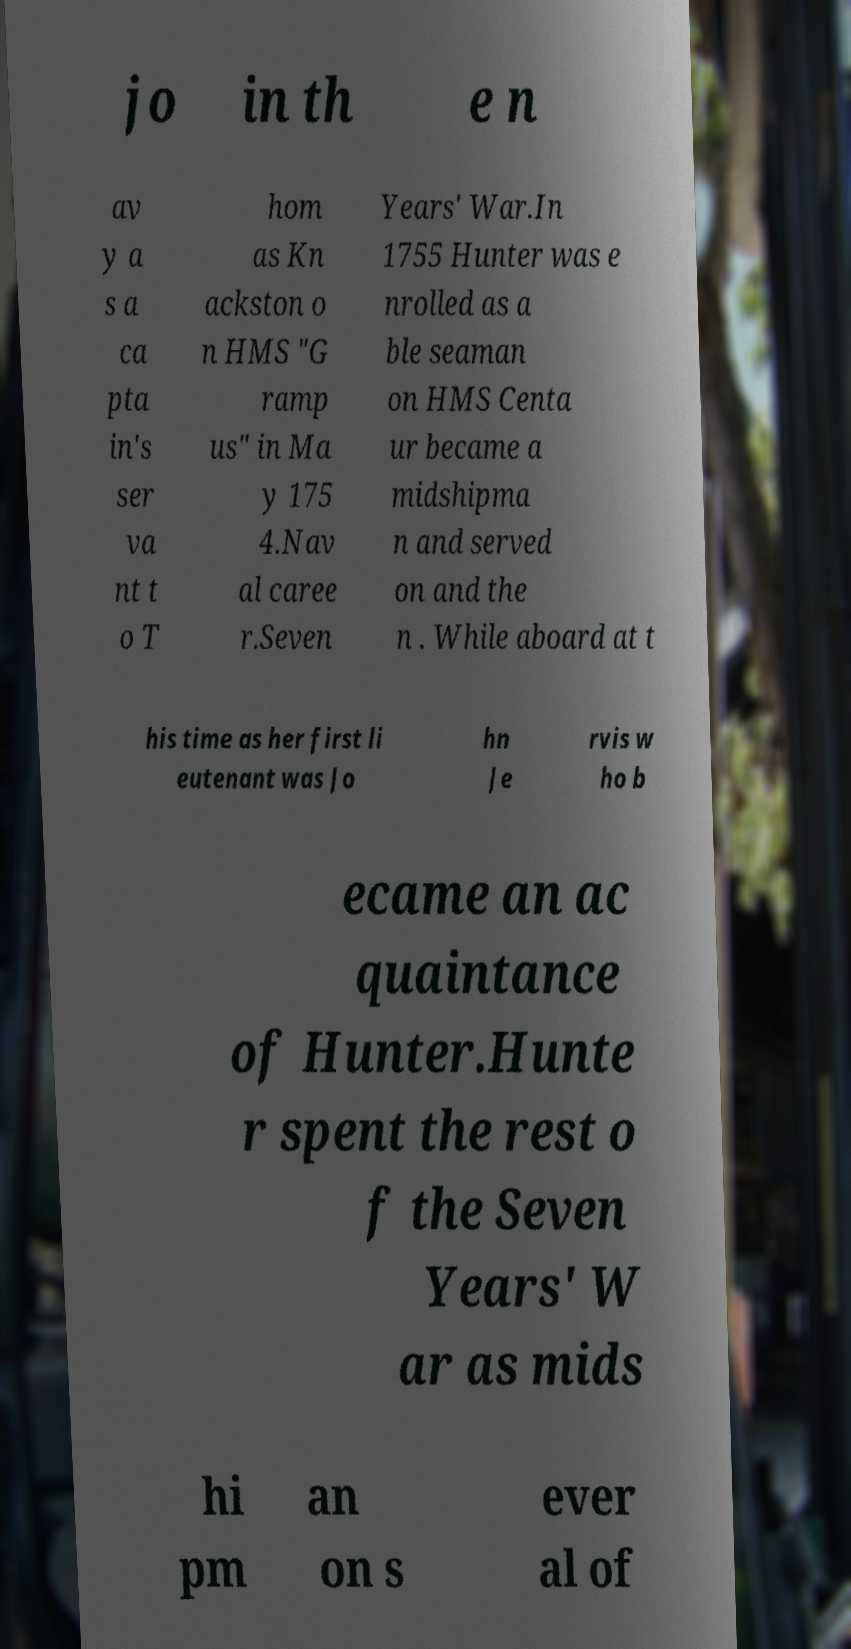Please read and relay the text visible in this image. What does it say? jo in th e n av y a s a ca pta in's ser va nt t o T hom as Kn ackston o n HMS "G ramp us" in Ma y 175 4.Nav al caree r.Seven Years' War.In 1755 Hunter was e nrolled as a ble seaman on HMS Centa ur became a midshipma n and served on and the n . While aboard at t his time as her first li eutenant was Jo hn Je rvis w ho b ecame an ac quaintance of Hunter.Hunte r spent the rest o f the Seven Years' W ar as mids hi pm an on s ever al of 